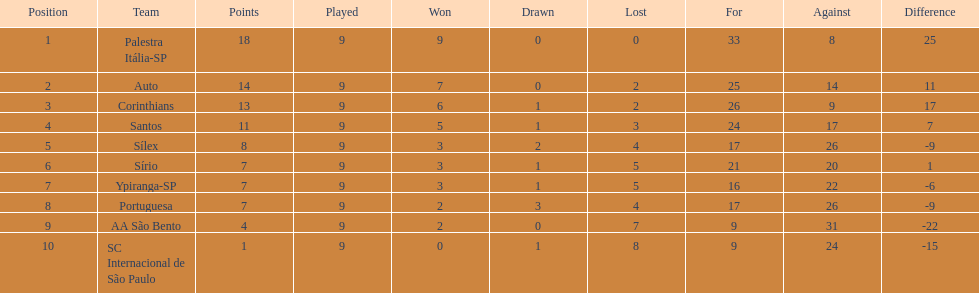Which teams were playing brazilian football in 1926? Palestra Itália-SP, Auto, Corinthians, Santos, Sílex, Sírio, Ypiranga-SP, Portuguesa, AA São Bento, SC Internacional de São Paulo. Of those teams, which one scored 13 points? Corinthians. 